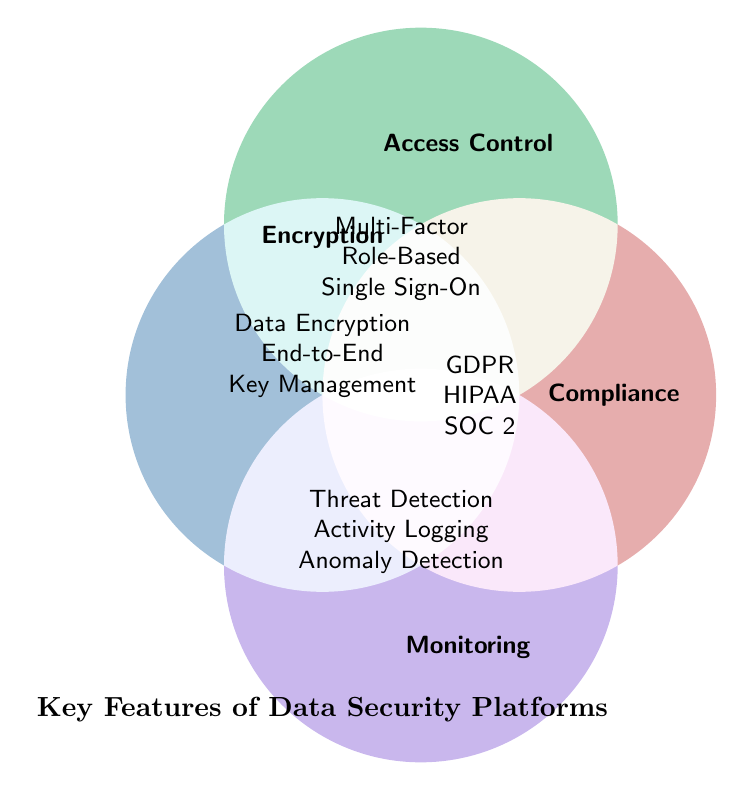What's the title of the figure? The notation “Key Features of Data Security Platforms” is prominently displayed at the bottom of the Venn Diagram, serving as the title.
Answer: Key Features of Data Security Platforms What are the four main categories represented in the Venn Diagram? The figure has titles placed at the top of four overlapping circles, each representing a category. These categories are "Encryption," "Access Control," "Compliance," and "Monitoring."
Answer: Encryption, Access Control, Compliance, Monitoring Which category lists "Multi-Factor Authentication" as a feature? By referring to the circle labeled “Access Control,” one can see the feature "Multi-Factor Authentication" listed there.
Answer: Access Control How many features are listed under the "Compliance" category? Within the "Compliance" circle, three text lines enumerate the features: GDPR Compliance, HIPAA Compliance, and SOC 2 Certification.
Answer: 3 Name two features that fall under the "Monitoring" category. The circle denoted as “Monitoring” enlists several features, from which "Real-Time Threat Detection" and "User Activity Logging" can be found.
Answer: Real-Time Threat Detection, User Activity Logging Do any features overlap between the "Encryption" and "Access Control" categories? By inspecting the overlapping sections of the "Encryption" and "Access Control" circles, there is no shared text, indicating no shared features between these categories.
Answer: No Which category contains the feature "End-to-End Encryption"? By examining the circle named "Encryption," it includes the feature "End-to-End Encryption" among its listed attributes.
Answer: Encryption Which category includes more features: "Encryption" or "Monitoring"? Comparing the circles illustrated, “Encryption” has three features while "Monitoring" also contains exactly three features, making them equal in number.
Answer: Equal What are the common features in the categories "Monitoring" and "Compliance"? Observing the Venn Diagram, there is no overlapping segment or shared text between the "Monitoring" and "Compliance" circles, indicating no common features.
Answer: None 